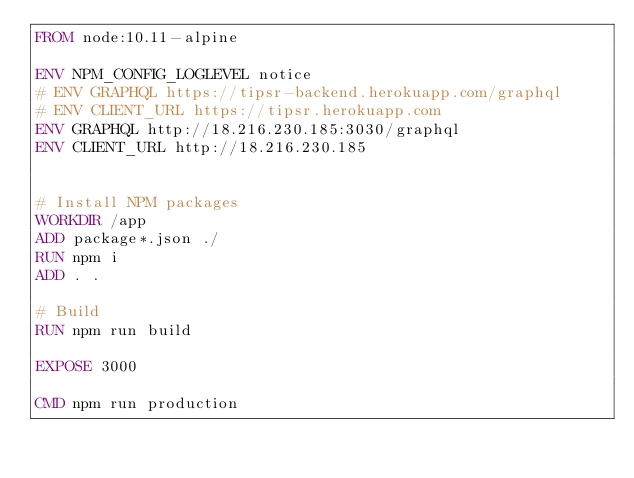Convert code to text. <code><loc_0><loc_0><loc_500><loc_500><_Dockerfile_>FROM node:10.11-alpine

ENV NPM_CONFIG_LOGLEVEL notice
# ENV GRAPHQL https://tipsr-backend.herokuapp.com/graphql
# ENV CLIENT_URL https://tipsr.herokuapp.com
ENV GRAPHQL http://18.216.230.185:3030/graphql
ENV CLIENT_URL http://18.216.230.185


# Install NPM packages
WORKDIR /app
ADD package*.json ./
RUN npm i
ADD . .

# Build
RUN npm run build

EXPOSE 3000

CMD npm run production
</code> 